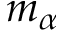<formula> <loc_0><loc_0><loc_500><loc_500>m _ { \alpha }</formula> 